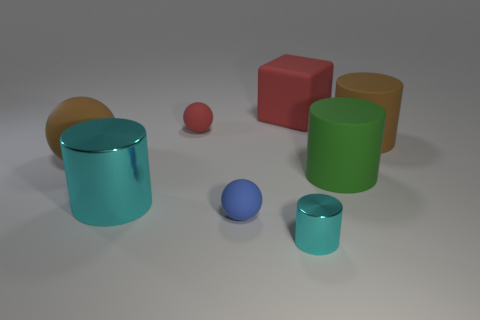Are there any small gray blocks that have the same material as the green cylinder?
Give a very brief answer. No. What material is the block that is the same size as the green cylinder?
Your answer should be compact. Rubber. What is the color of the small matte sphere behind the big cylinder that is on the left side of the tiny ball that is behind the large brown rubber cylinder?
Your answer should be very brief. Red. Do the large brown matte thing that is left of the tiny cyan cylinder and the brown rubber object that is behind the large sphere have the same shape?
Your answer should be very brief. No. What number of matte cubes are there?
Offer a very short reply. 1. What color is the metallic cylinder that is the same size as the red block?
Keep it short and to the point. Cyan. Do the brown object that is to the left of the large red rubber block and the green object that is in front of the tiny red rubber ball have the same material?
Offer a terse response. Yes. What is the size of the brown rubber object that is left of the cyan thing that is to the left of the tiny cylinder?
Your response must be concise. Large. There is a cyan cylinder to the right of the large metallic cylinder; what is it made of?
Provide a short and direct response. Metal. How many things are either objects that are left of the small cylinder or things that are in front of the large cyan cylinder?
Your answer should be compact. 5. 